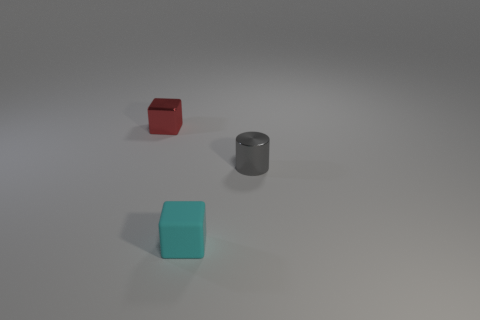Add 2 cyan things. How many objects exist? 5 Subtract all blocks. How many objects are left? 1 Add 1 small gray shiny objects. How many small gray shiny objects exist? 2 Subtract 0 green balls. How many objects are left? 3 Subtract all small blocks. Subtract all green spheres. How many objects are left? 1 Add 1 cyan rubber objects. How many cyan rubber objects are left? 2 